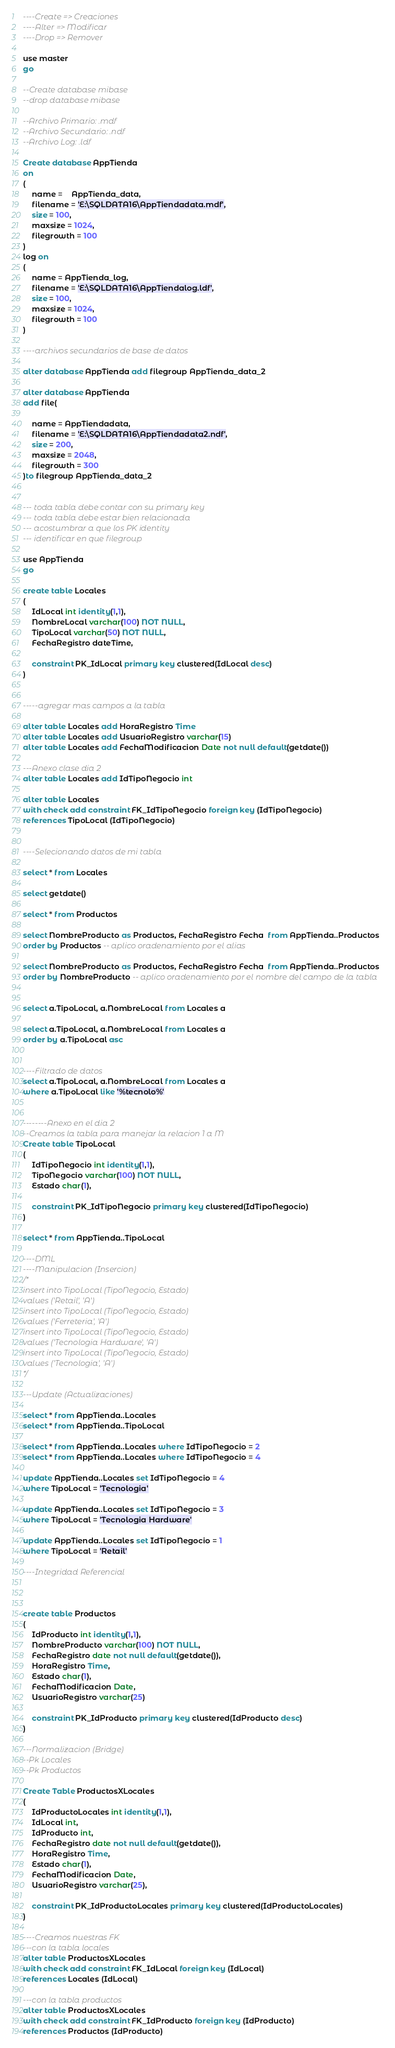Convert code to text. <code><loc_0><loc_0><loc_500><loc_500><_SQL_>
----Create => Creaciones
----Alter => Modificar
----Drop => Remover

use master
go

--Create database mibase
--drop database mibase

--Archivo Primario: .mdf
--Archivo Secundario: .ndf
--Archivo Log: .ldf

Create database AppTienda
on
(
	name = 	AppTienda_data,
	filename = 'E:\SQLDATA16\AppTiendadata.mdf',
	size = 100,
	maxsize = 1024,
	filegrowth = 100
)
log on
(
	name = AppTienda_log,
	filename = 'E:\SQLDATA16\AppTiendalog.ldf',
	size = 100,
	maxsize = 1024,
	filegrowth = 100
)

----archivos secundarios de base de datos

alter database AppTienda add filegroup AppTienda_data_2

alter database AppTienda
add file(
	
	name = AppTiendadata,
	filename = 'E:\SQLDATA16\AppTiendadata2.ndf',
	size = 200,
	maxsize = 2048,
	filegrowth = 300
)to filegroup AppTienda_data_2


--- toda tabla debe contar con su primary key
--- toda tabla debe estar bien relacionada
--- acostumbrar a que los PK identity
--- identificar en que filegroup

use AppTienda
go

create table Locales
(
	IdLocal int identity(1,1),
	NombreLocal varchar(100) NOT NULL,
	TipoLocal varchar(50) NOT NULL,
	FechaRegistro dateTime,

	constraint PK_IdLocal primary key clustered(IdLocal desc)
)


-----agregar mas campos a la tabla

alter table Locales add HoraRegistro Time
alter table Locales add UsuarioRegistro varchar(15)
alter table Locales add FechaModificacion Date not null default(getdate())

---Anexo clase dia 2
alter table Locales add IdTipoNegocio int

alter table Locales
with check add constraint FK_IdTipoNegocio foreign key (IdTipoNegocio)
references TipoLocal (IdTipoNegocio)


----Selecionando datos de mi tabla

select * from Locales

select getdate()

select * from Productos

select NombreProducto as Productos, FechaRegistro Fecha  from AppTienda..Productos
order by Productos -- aplico oradenamiento por el alias

select NombreProducto as Productos, FechaRegistro Fecha  from AppTienda..Productos
order by NombreProducto -- aplico oradenamiento por el nombre del campo de la tabla


select a.TipoLocal, a.NombreLocal from Locales a

select a.TipoLocal, a.NombreLocal from Locales a
order by a.TipoLocal asc


----Filtrado de datos
select a.TipoLocal, a.NombreLocal from Locales a
where a.TipoLocal like '%tecnolo%'


--------Anexo en el dia 2
--Creamos la tabla para manejar la relacion 1 a M
Create table TipoLocal
(
	IdTipoNegocio int identity(1,1),
	TipoNegocio varchar(100) NOT NULL,
	Estado char(1),

	constraint PK_IdTipoNegocio primary key clustered(IdTipoNegocio)
)

select * from AppTienda..TipoLocal

----DML
----Manipulacion (Insercion)
/*
insert into TipoLocal (TipoNegocio, Estado)
values ('Retail', 'A')
insert into TipoLocal (TipoNegocio, Estado)
values ('Ferreteria', 'A')
insert into TipoLocal (TipoNegocio, Estado)
values ('Tecnologia Hardware', 'A')
insert into TipoLocal (TipoNegocio, Estado)
values ('Tecnologia', 'A')
*/

---Update (Actualizaciones)

select * from AppTienda..Locales
select * from AppTienda..TipoLocal

select * from AppTienda..Locales where IdTipoNegocio = 2
select * from AppTienda..Locales where IdTipoNegocio = 4

update AppTienda..Locales set IdTipoNegocio = 4
where TipoLocal = 'Tecnologia'

update AppTienda..Locales set IdTipoNegocio = 3
where TipoLocal = 'Tecnologia Hardware'

update AppTienda..Locales set IdTipoNegocio = 1
where TipoLocal = 'Retail'

----Integridad Referencial



create table Productos
(
	IdProducto int identity(1,1),
	NombreProducto varchar(100) NOT NULL,
	FechaRegistro date not null default(getdate()),
	HoraRegistro Time,
	Estado char(1),
	FechaModificacion Date,
	UsuarioRegistro varchar(25)
	
	constraint PK_IdProducto primary key clustered(IdProducto desc)
)

---Normalizacion (Bridge)
--Pk Locales
--Pk Productos

Create Table ProductosXLocales
(
	IdProductoLocales int identity(1,1),
	IdLocal int,
	IdProducto int,
	FechaRegistro date not null default(getdate()),
	HoraRegistro Time,
	Estado char(1),
	FechaModificacion Date,
	UsuarioRegistro varchar(25),

	constraint PK_IdProductoLocales primary key clustered(IdProductoLocales)
)

----Creamos nuestras FK
---con la tabla locales
alter table ProductosXLocales
with check add constraint FK_IdLocal foreign key (IdLocal)
references Locales (IdLocal)

---con la tabla productos
alter table ProductosXLocales
with check add constraint FK_IdProducto foreign key (IdProducto)
references Productos (IdProducto)

</code> 